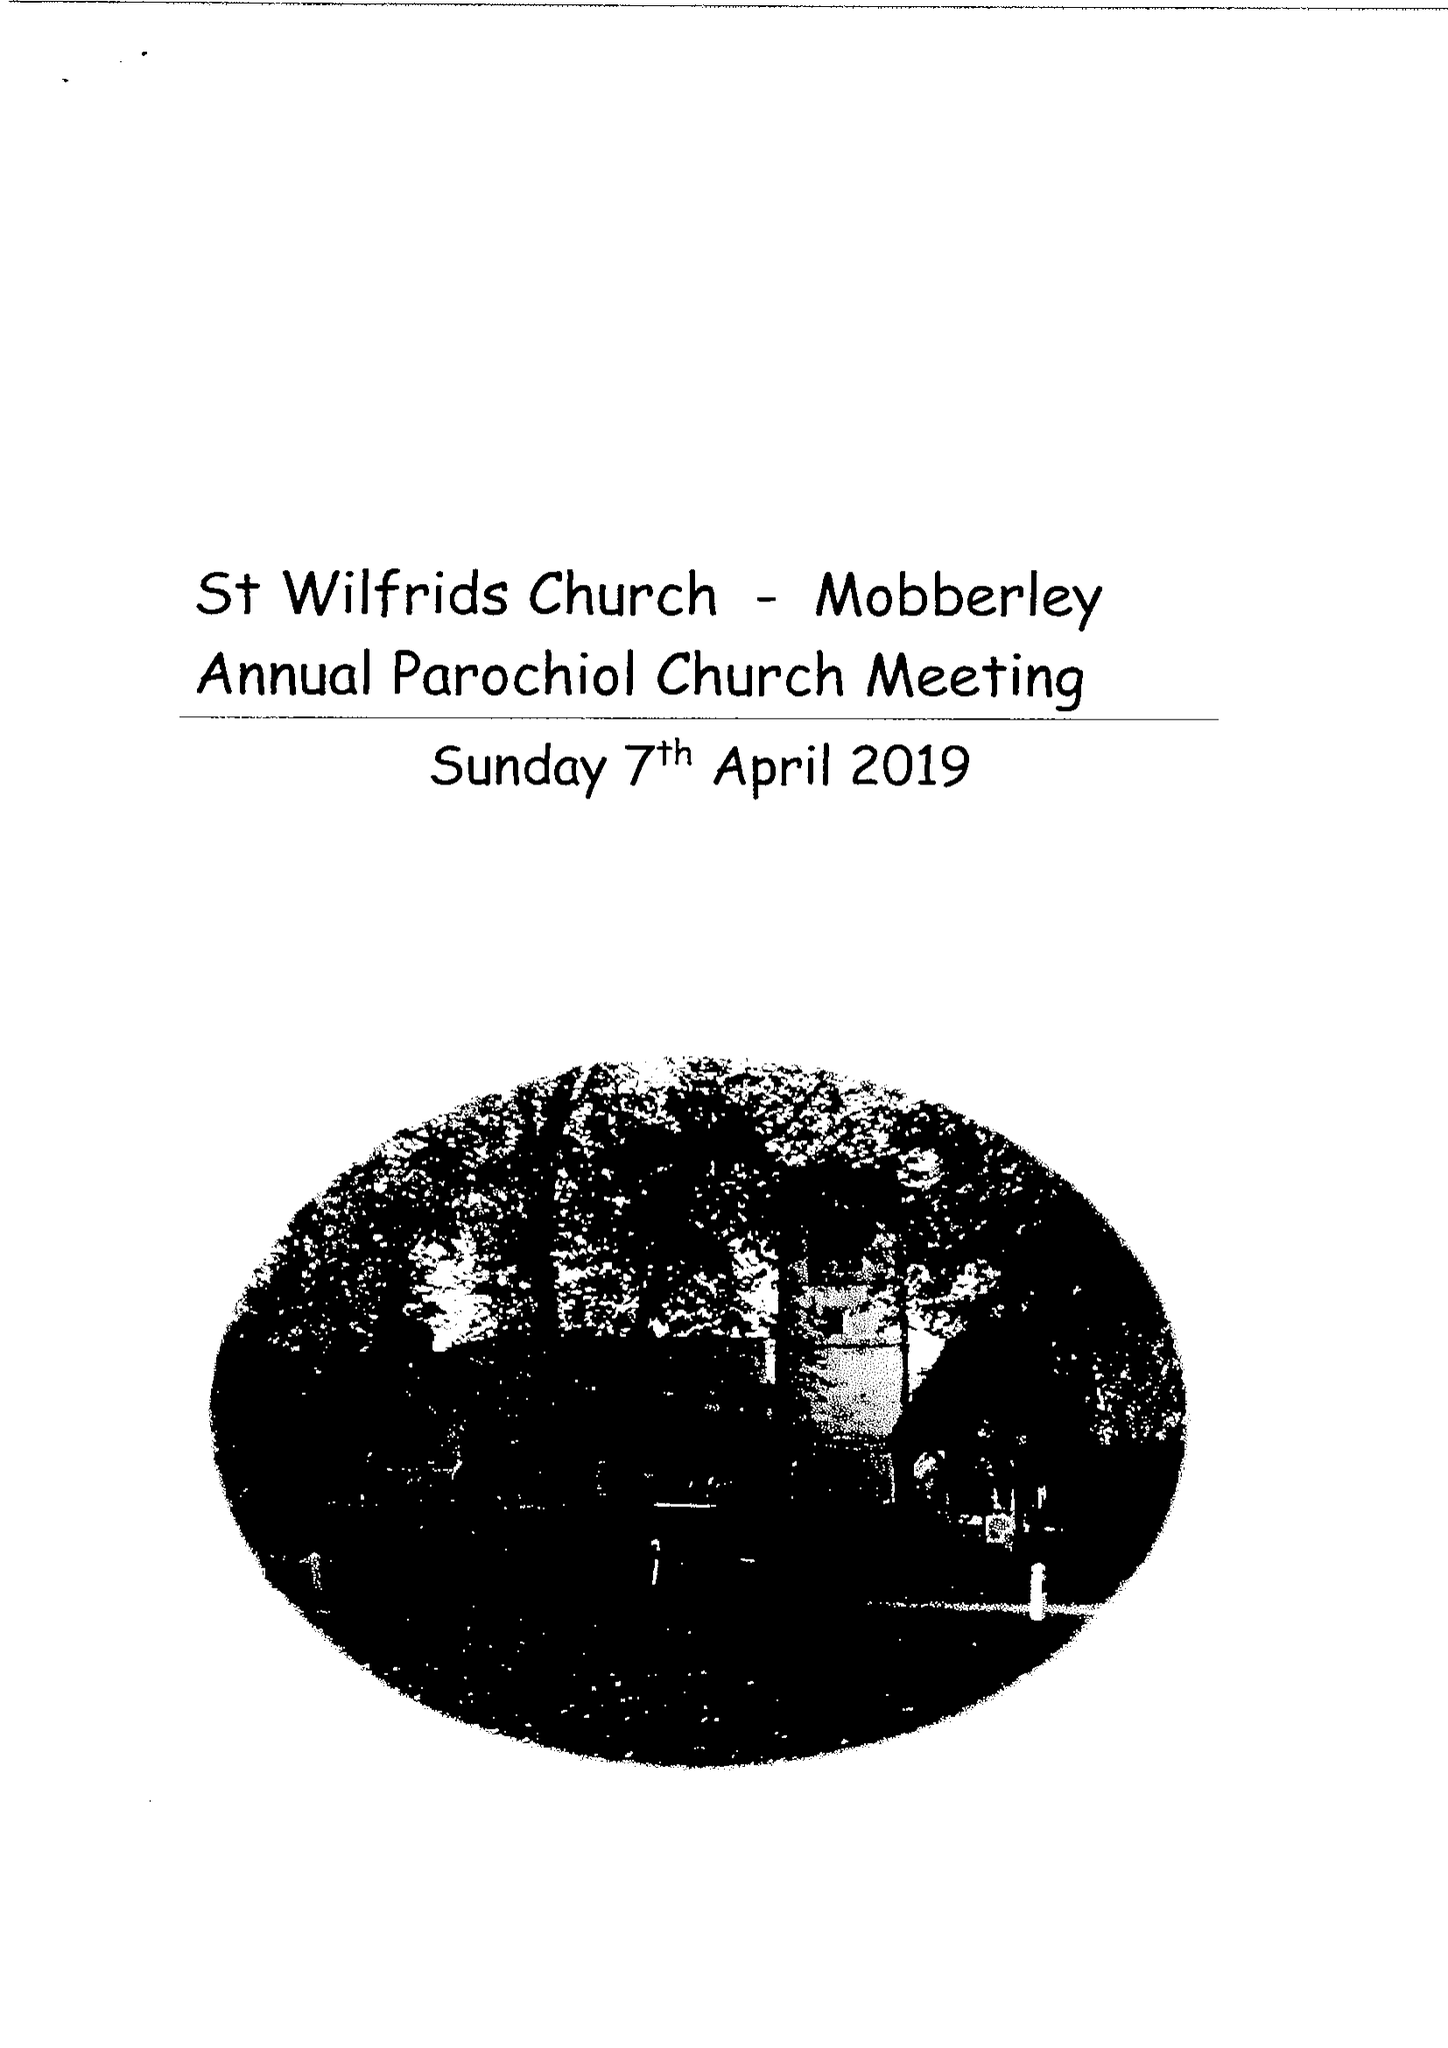What is the value for the charity_number?
Answer the question using a single word or phrase. 1146680 